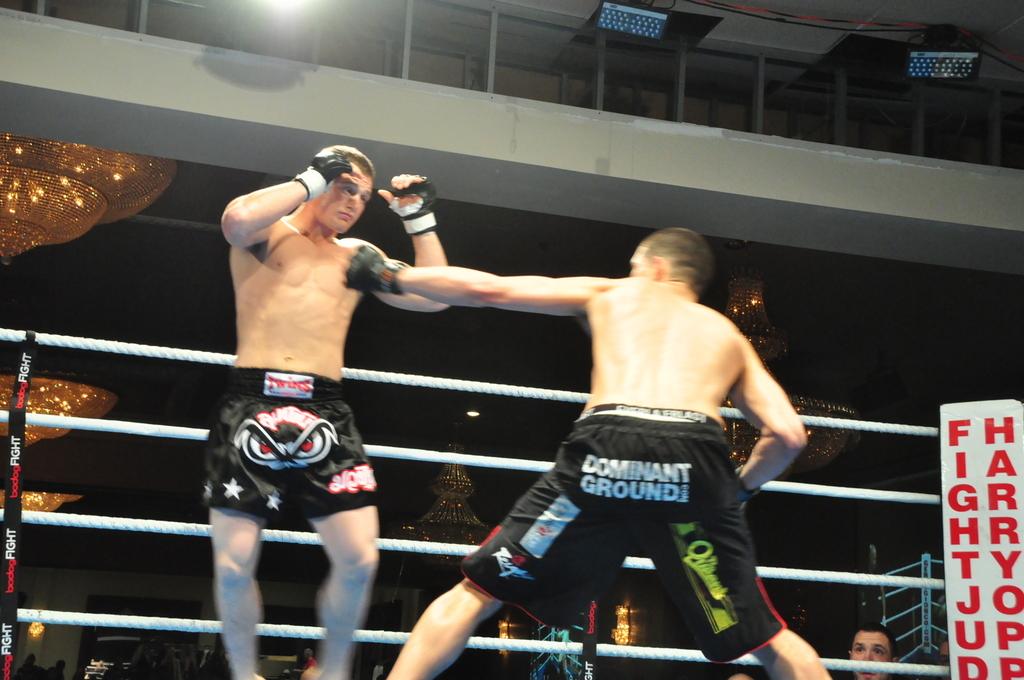Who sponsors the fighter on the right?
Provide a short and direct response. Dominant ground. 